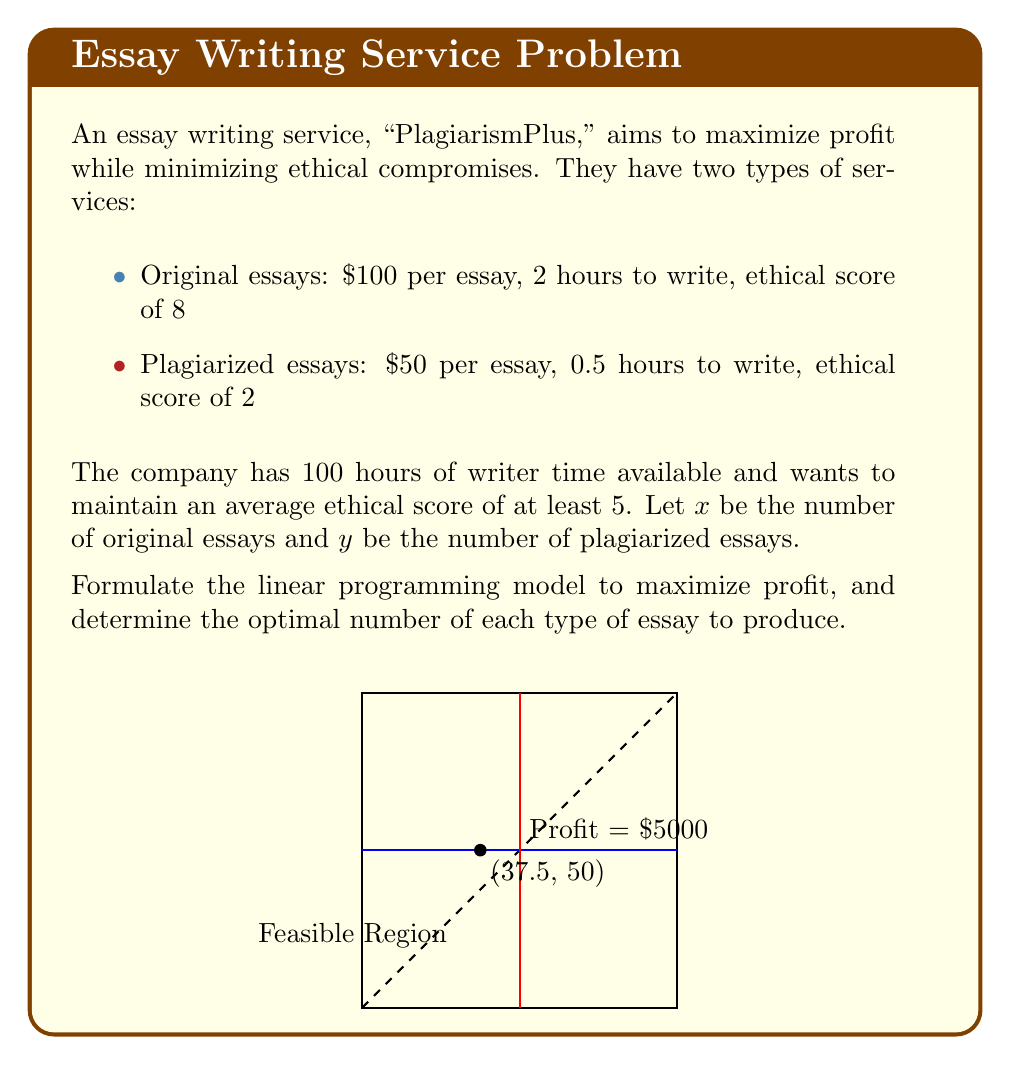Help me with this question. Let's approach this step-by-step:

1) First, we need to define our objective function. We want to maximize profit:
   $$ \text{Maximize } Z = 100x + 50y $$

2) Now, let's define our constraints:

   a) Time constraint: $2x + 0.5y \leq 100$
   
   b) Ethical score constraint: We want the average ethical score to be at least 5.
      $$ \frac{8x + 2y}{x + y} \geq 5 $$
      This can be rewritten as: $8x + 2y \geq 5x + 5y$, or $3x - 3y \geq 0$

   c) Non-negativity constraints: $x \geq 0, y \geq 0$

3) Our complete linear programming model:

   $$ \text{Maximize } Z = 100x + 50y $$
   $$ \text{Subject to:} $$
   $$ 2x + 0.5y \leq 100 $$
   $$ 3x - 3y \geq 0 $$
   $$ x, y \geq 0 $$

4) To solve this, we can use the graphical method. The feasible region is bounded by the constraints.

5) The optimal solution will be at one of the corner points of the feasible region. We need to find the corner point that gives the highest value of Z.

6) The corner points are (0,0), (50,0), (37.5,50), and (0,200). However, (0,200) is outside our feasible region due to the time constraint.

7) Evaluating Z at each point:
   - Z(0,0) = 0
   - Z(50,0) = 5000
   - Z(37.5,50) = 6250

8) The maximum profit is achieved at the point (37.5, 50), which means producing 37.5 original essays and 50 plagiarized essays.
Answer: 37.5 original essays, 50 plagiarized essays; Maximum profit: $6250 